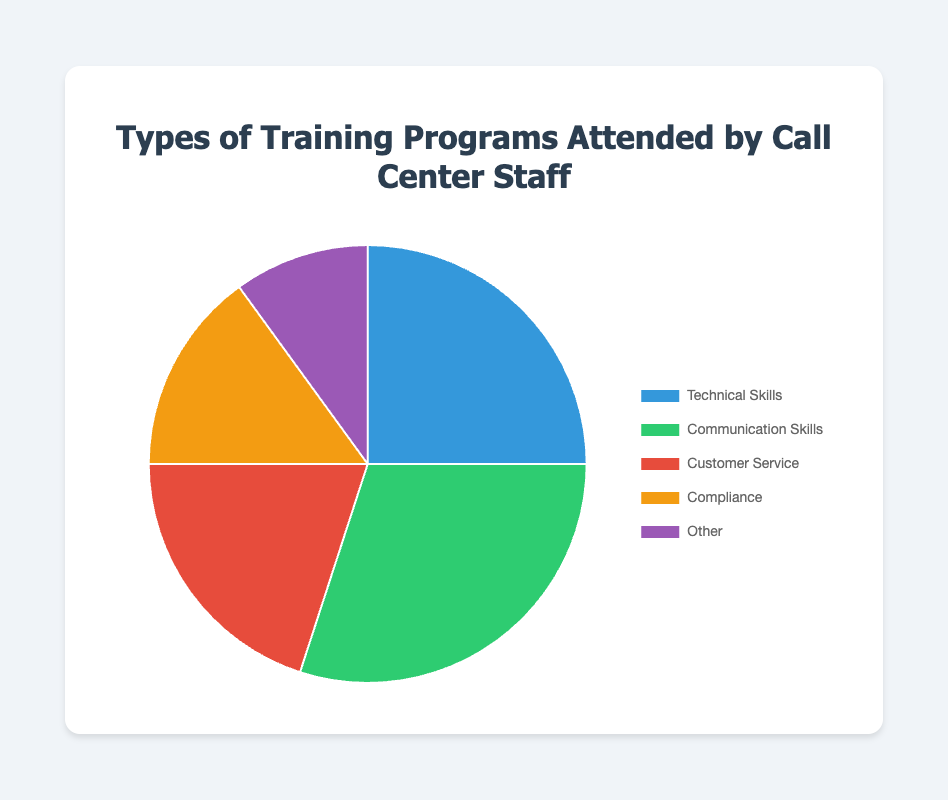What type of training program had the highest attendance? By looking at the pie chart, we can see that the section labeled "Communication Skills" occupies the largest portion of the chart.
Answer: Communication Skills Which training type has the least attendance? By observing the size of the sections in the pie chart, the "Other" category has the smallest slice, indicating the lowest attendance.
Answer: Other How many types of training programs have attendance rates above 20%? From the chart, we identify that "Technical Skills" at 25% and "Communication Skills" at 30% both have attendance rates above 20%.
Answer: 2 What is the combined percentage of attendees in "Technical Skills" and "Customer Service" programs? Adding the percentages for "Technical Skills" (25%) and "Customer Service" (20%) gives us 45%.
Answer: 45% Which is higher, the sum of "Compliance" and "Other" or "Customer Service" alone? The combined percentage for "Compliance" (15%) and "Other" (10%) is 25%, which is greater than the 20% for "Customer Service".
Answer: Compliance and Other What percentage more attended "Communication Skills" compared to "Compliance"? The percentage for "Communication Skills" is 30%, and for "Compliance" it is 15%. The difference is 30% - 15% = 15%.
Answer: 15% Is the attendance for "Technical Skills" less than half of the attendance for "Communication Skills"? "Technical Skills" has a 25% attendance rate, while "Communication Skills" is at 30%. Half of 30% is 15%, which is less than 25%. So, no, it is not less.
Answer: No Which section of the pie chart is colored green? The green section corresponds to the "Communication Skills" training program.
Answer: Communication Skills What is the difference in attendance percentages between the largest and smallest training program categories? The difference is between "Communication Skills" at 30% and "Other" at 10%, calculated as 30% - 10% = 20%.
Answer: 20% What two categories together make up exactly half of the pie chart? The combined percentages of "Technical Skills" (25%) and "Customer Service" (20%) do not make 50%, but "Communication Skills" (30%) and "Compliance" (15%) also don't add to 50%. "Technical Skills" (25%) and "Communication Skills" (30%) give 55%, so there aren't two categories that make exactly 50%.
Answer: None 